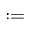Convert formula to latex. <formula><loc_0><loc_0><loc_500><loc_500>\colon =</formula> 